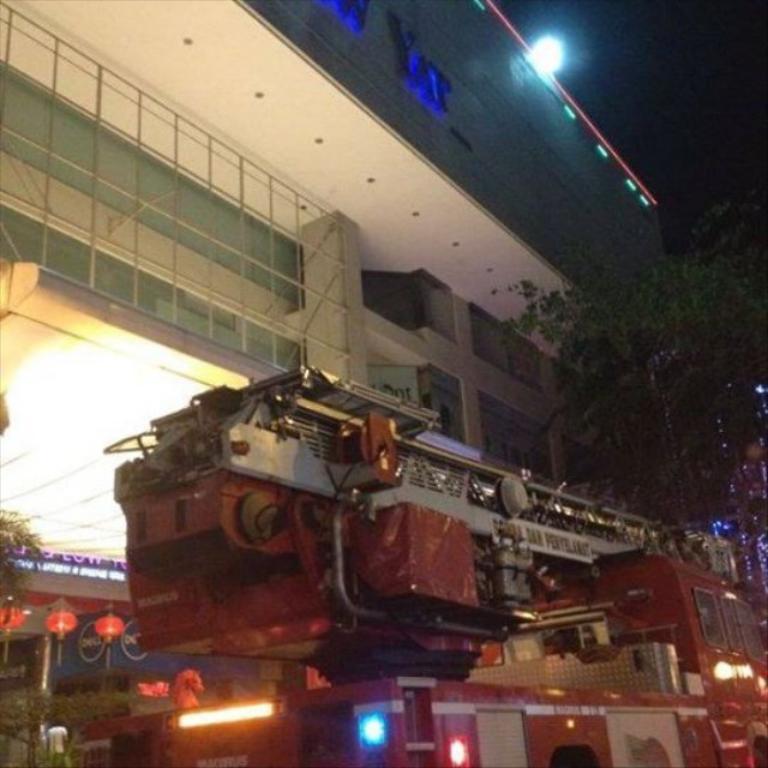In one or two sentences, can you explain what this image depicts? In the image we can see there is a fire extinguisher on the ground. Behind there are trees and there is a building. 